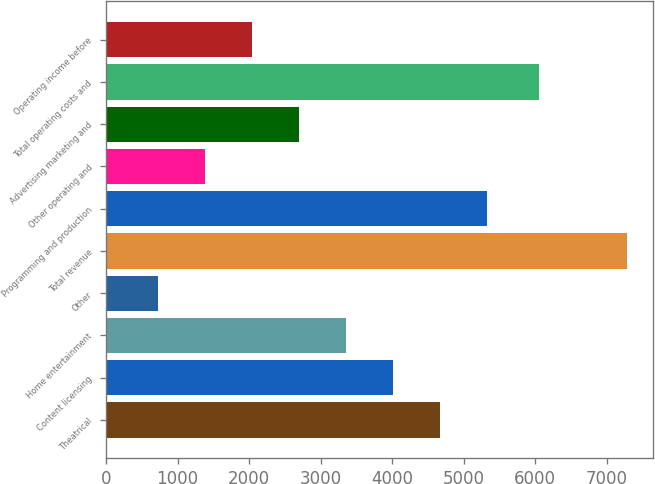Convert chart. <chart><loc_0><loc_0><loc_500><loc_500><bar_chart><fcel>Theatrical<fcel>Content licensing<fcel>Home entertainment<fcel>Other<fcel>Total revenue<fcel>Programming and production<fcel>Other operating and<fcel>Advertising marketing and<fcel>Total operating costs and<fcel>Operating income before<nl><fcel>4665.8<fcel>4010.5<fcel>3355.2<fcel>734<fcel>7287<fcel>5321.1<fcel>1389.3<fcel>2699.9<fcel>6053<fcel>2044.6<nl></chart> 